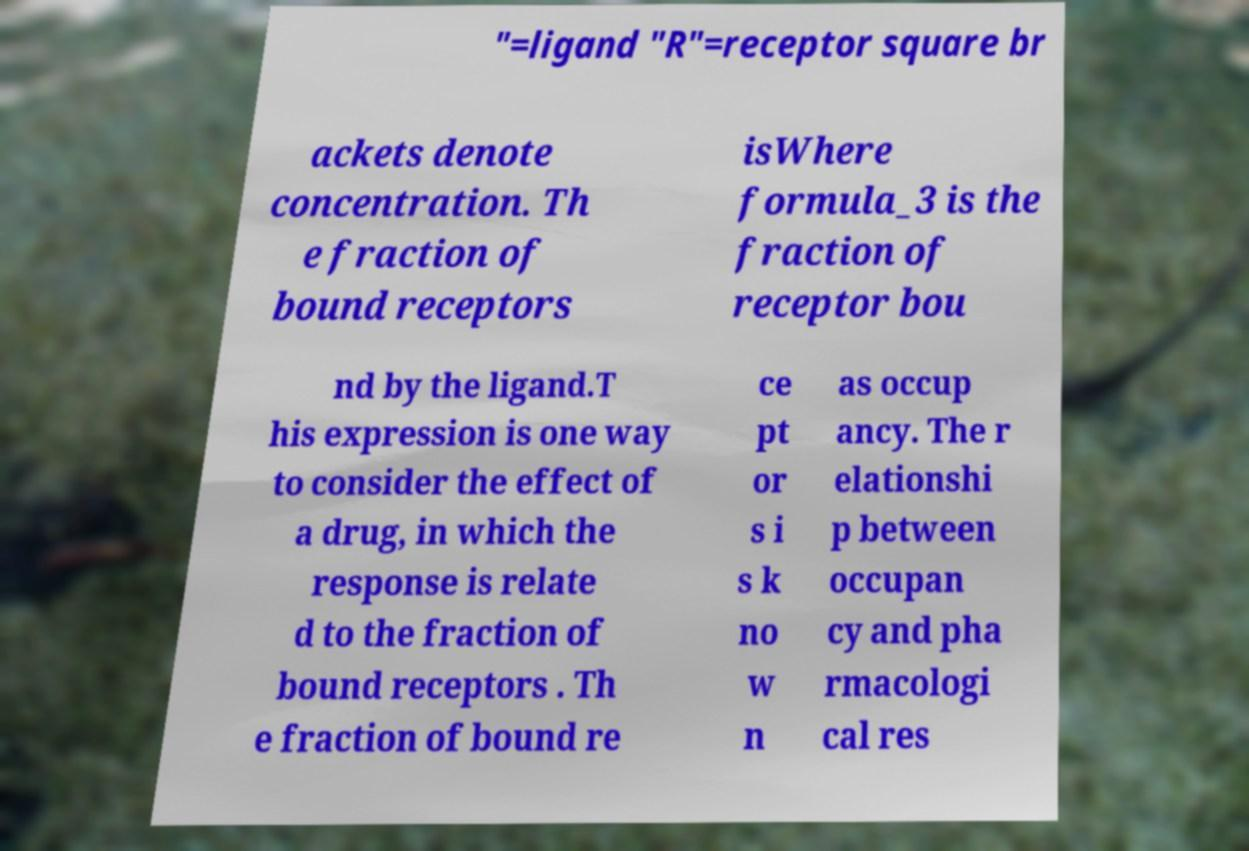There's text embedded in this image that I need extracted. Can you transcribe it verbatim? "=ligand "R"=receptor square br ackets denote concentration. Th e fraction of bound receptors isWhere formula_3 is the fraction of receptor bou nd by the ligand.T his expression is one way to consider the effect of a drug, in which the response is relate d to the fraction of bound receptors . Th e fraction of bound re ce pt or s i s k no w n as occup ancy. The r elationshi p between occupan cy and pha rmacologi cal res 